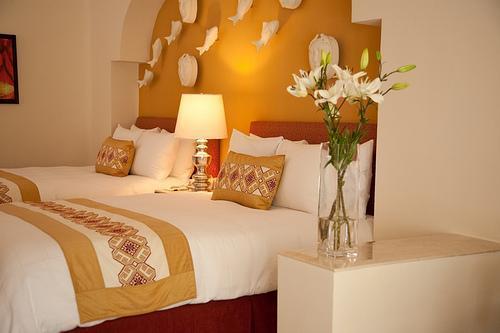How many pillows are on each bed?
Give a very brief answer. 5. How many lights are in the picture?
Give a very brief answer. 1. How many night stands are in the picture?
Give a very brief answer. 2. How many lamps are there?
Give a very brief answer. 1. How many beds are there?
Give a very brief answer. 2. How many bottles are seen?
Give a very brief answer. 0. 